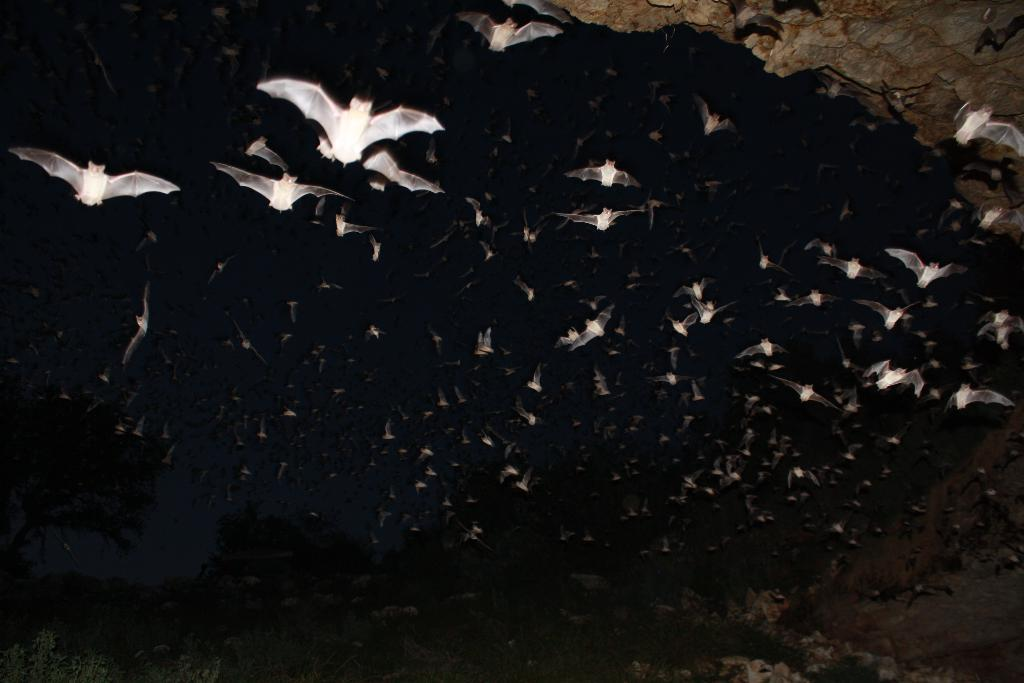What animals are present in the image? There are bats in the image. What color are the bats? The bats are white in color. What can be observed about the background of the image? The background of the image is dark. What type of machine is being used by the bats in the image? There is no machine present in the image; it features white bats against a dark background. 